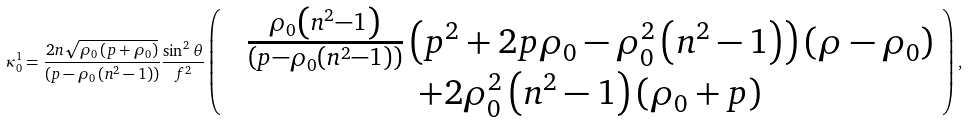Convert formula to latex. <formula><loc_0><loc_0><loc_500><loc_500>\kappa ^ { 1 } _ { 0 } = \frac { 2 n \sqrt { \rho _ { 0 } \left ( p + \rho _ { 0 } \right ) } } { \left ( p - \rho _ { 0 } \left ( n ^ { 2 } - 1 \right ) \right ) } \frac { \sin ^ { 2 } \theta } { f ^ { 2 } } \left ( \begin{array} { c c } & \frac { \rho _ { 0 } \left ( n ^ { 2 } - 1 \right ) } { \left ( p - \rho _ { 0 } \left ( n ^ { 2 } - 1 \right ) \right ) } \left ( p ^ { 2 } + 2 p \rho _ { 0 } - \rho _ { 0 } ^ { 2 } \left ( n ^ { 2 } - 1 \right ) \right ) \left ( \rho - \rho _ { 0 } \right ) \\ & + 2 \rho _ { 0 } ^ { 2 } \left ( n ^ { 2 } - 1 \right ) \left ( \rho _ { 0 } + p \right ) \end{array} \right ) ,</formula> 